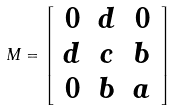Convert formula to latex. <formula><loc_0><loc_0><loc_500><loc_500>M = \left [ \begin{array} { c c c } 0 & d & 0 \\ d & c & b \\ 0 & b & a \end{array} \right ]</formula> 